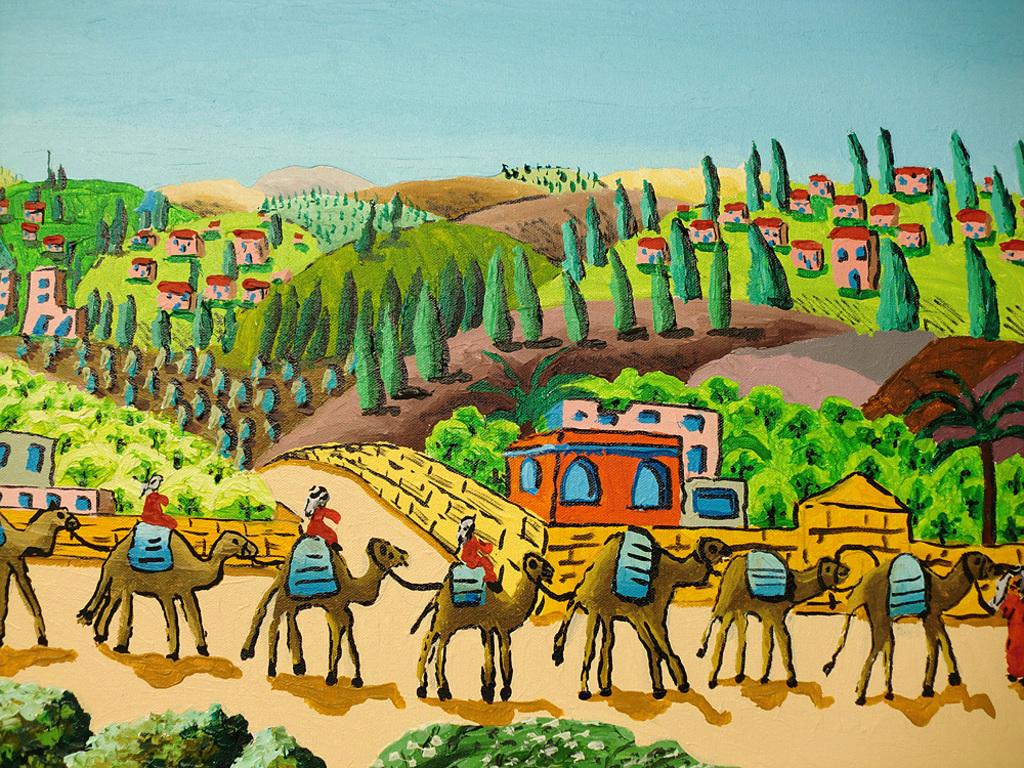What type of artwork is depicted in the image? The image is a painting. What types of animals can be seen in the painting? There are images of camels in the painting. What types of structures are present in the painting? There are images of houses in the painting. What type of pathways are shown in the painting? There are images of roads in the painting. What type of vegetation is depicted in the painting? There are images of trees and greenery in the painting. What type of natural landforms are visible in the painting? There are images of mountains in the painting. What type of kitty can be seen playing with a map in the painting? There is no kitty or map present in the painting; it features images of camels, houses, roads, trees, greenery, and mountains. What type of suggestion is given by the painting? The painting does not provide any suggestions; it is a visual representation of various elements and subjects. 